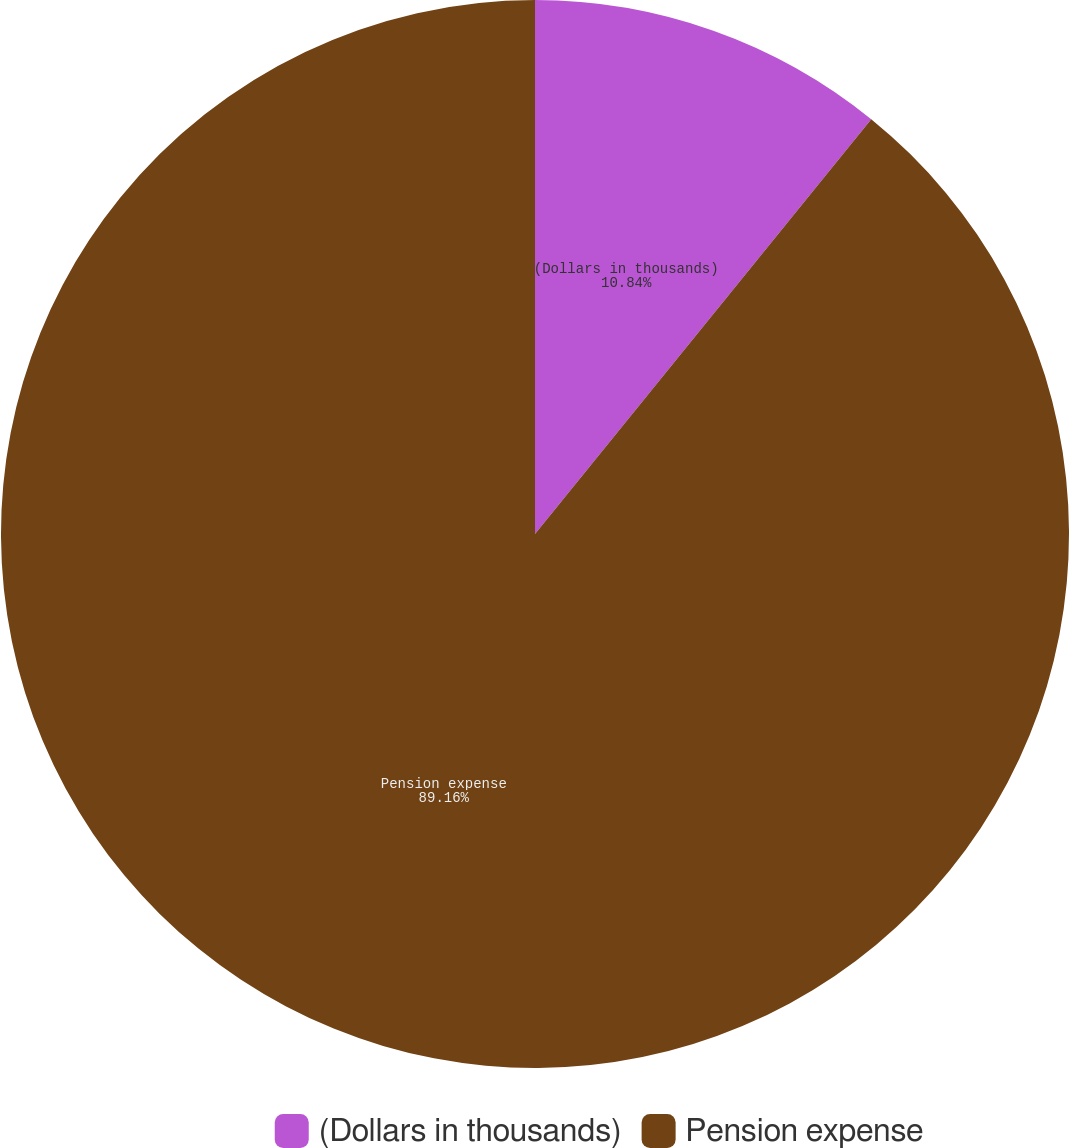Convert chart to OTSL. <chart><loc_0><loc_0><loc_500><loc_500><pie_chart><fcel>(Dollars in thousands)<fcel>Pension expense<nl><fcel>10.84%<fcel>89.16%<nl></chart> 